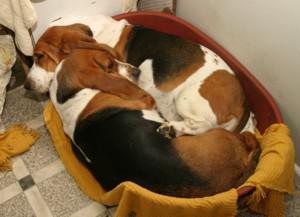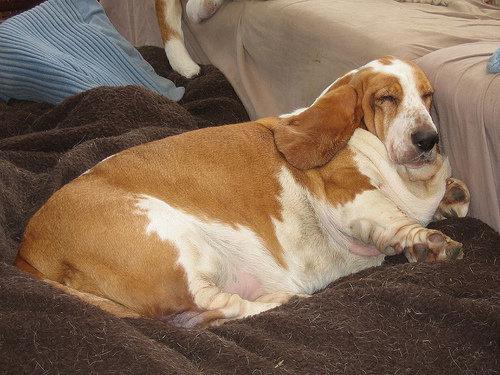The first image is the image on the left, the second image is the image on the right. Evaluate the accuracy of this statement regarding the images: "One image shows two adult basset hounds sleeping in a round dog bed together". Is it true? Answer yes or no. Yes. The first image is the image on the left, the second image is the image on the right. Given the left and right images, does the statement "Two basset hounds snuggle together in a round pet bed, in one image." hold true? Answer yes or no. Yes. 